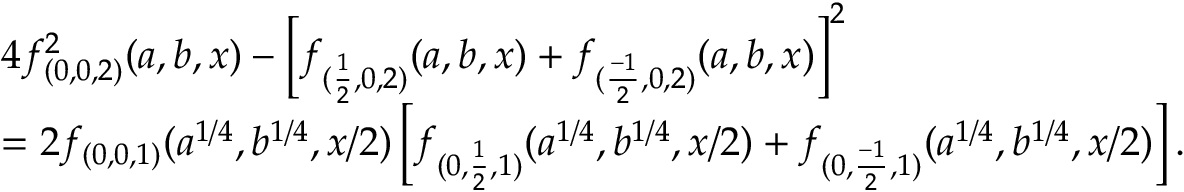<formula> <loc_0><loc_0><loc_500><loc_500>\begin{array} { r l } & { 4 f _ { ( 0 , 0 , 2 ) } ^ { 2 } ( a , b , x ) - \left [ f _ { ( \frac { 1 } { 2 } , 0 , 2 ) } ( a , b , x ) + f _ { ( \frac { - 1 } { 2 } , 0 , 2 ) } ( a , b , x ) \right ] ^ { 2 } } \\ & { = 2 f _ { ( 0 , 0 , 1 ) } ( a ^ { 1 / 4 } , b ^ { 1 / 4 } , x / 2 ) \left [ f _ { ( 0 , \frac { 1 } { 2 } , 1 ) } ( a ^ { 1 / 4 } , b ^ { 1 / 4 } , x / 2 ) + f _ { ( 0 , \frac { - 1 } { 2 } , 1 ) } ( a ^ { 1 / 4 } , b ^ { 1 / 4 } , x / 2 ) \right ] . } \end{array}</formula> 